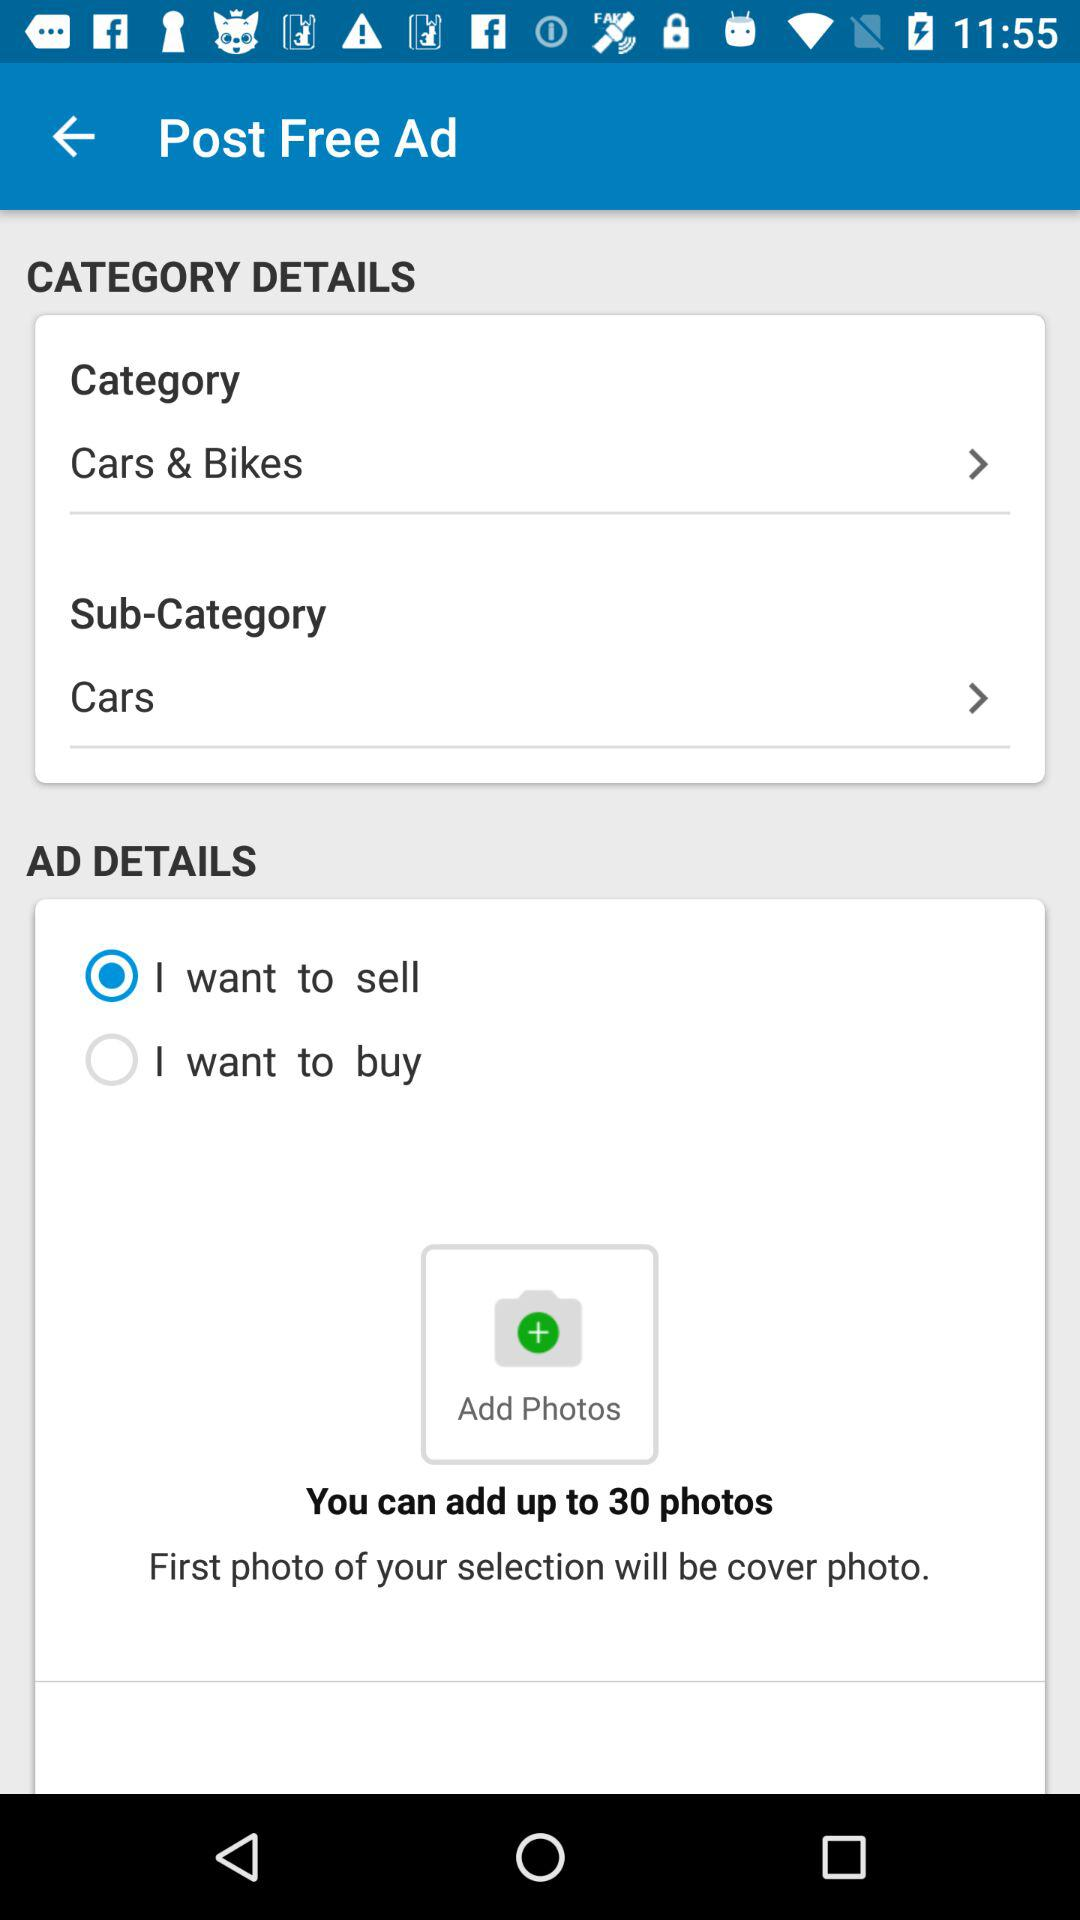Which option was selected? The selected options were "Cars & Bikes", "Cars" and "I want to sell". 